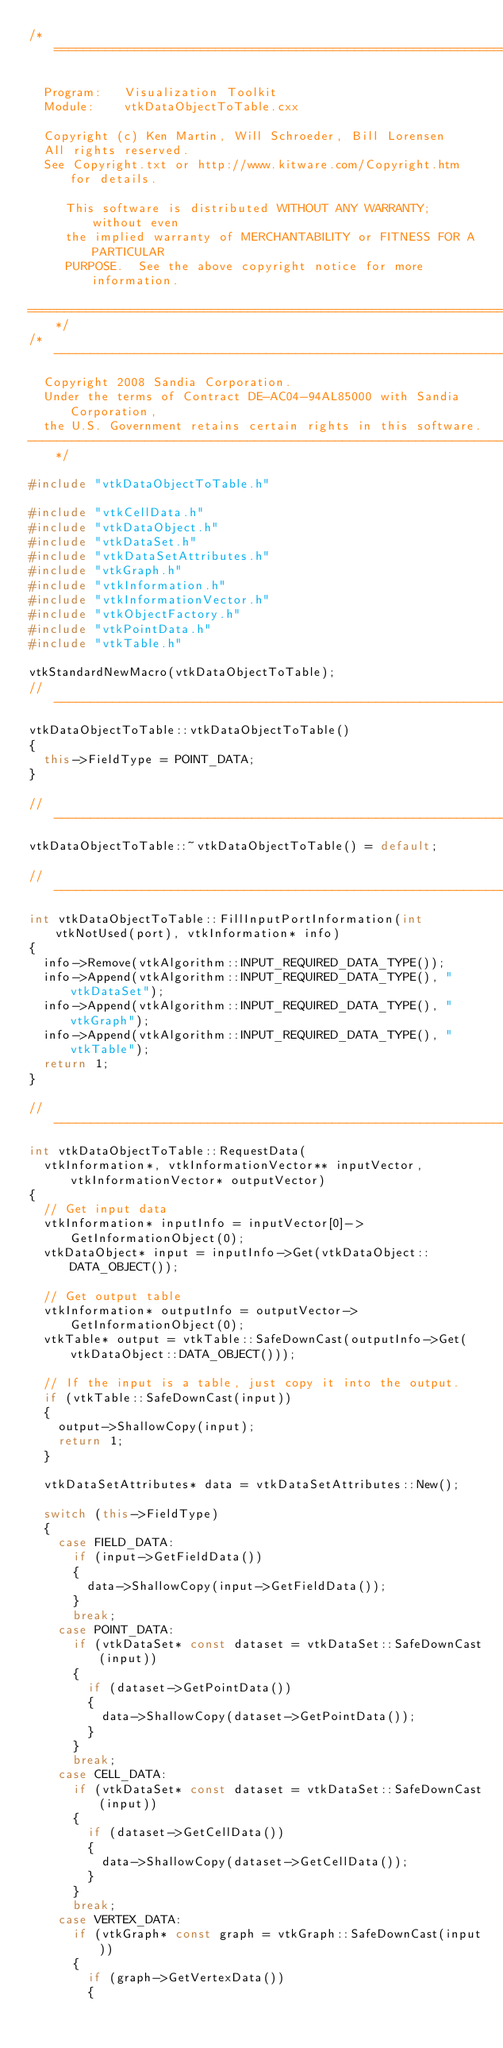Convert code to text. <code><loc_0><loc_0><loc_500><loc_500><_C++_>/*=========================================================================

  Program:   Visualization Toolkit
  Module:    vtkDataObjectToTable.cxx

  Copyright (c) Ken Martin, Will Schroeder, Bill Lorensen
  All rights reserved.
  See Copyright.txt or http://www.kitware.com/Copyright.htm for details.

     This software is distributed WITHOUT ANY WARRANTY; without even
     the implied warranty of MERCHANTABILITY or FITNESS FOR A PARTICULAR
     PURPOSE.  See the above copyright notice for more information.

=========================================================================*/
/*-------------------------------------------------------------------------
  Copyright 2008 Sandia Corporation.
  Under the terms of Contract DE-AC04-94AL85000 with Sandia Corporation,
  the U.S. Government retains certain rights in this software.
-------------------------------------------------------------------------*/

#include "vtkDataObjectToTable.h"

#include "vtkCellData.h"
#include "vtkDataObject.h"
#include "vtkDataSet.h"
#include "vtkDataSetAttributes.h"
#include "vtkGraph.h"
#include "vtkInformation.h"
#include "vtkInformationVector.h"
#include "vtkObjectFactory.h"
#include "vtkPointData.h"
#include "vtkTable.h"

vtkStandardNewMacro(vtkDataObjectToTable);
//------------------------------------------------------------------------------
vtkDataObjectToTable::vtkDataObjectToTable()
{
  this->FieldType = POINT_DATA;
}

//------------------------------------------------------------------------------
vtkDataObjectToTable::~vtkDataObjectToTable() = default;

//------------------------------------------------------------------------------
int vtkDataObjectToTable::FillInputPortInformation(int vtkNotUsed(port), vtkInformation* info)
{
  info->Remove(vtkAlgorithm::INPUT_REQUIRED_DATA_TYPE());
  info->Append(vtkAlgorithm::INPUT_REQUIRED_DATA_TYPE(), "vtkDataSet");
  info->Append(vtkAlgorithm::INPUT_REQUIRED_DATA_TYPE(), "vtkGraph");
  info->Append(vtkAlgorithm::INPUT_REQUIRED_DATA_TYPE(), "vtkTable");
  return 1;
}

//------------------------------------------------------------------------------
int vtkDataObjectToTable::RequestData(
  vtkInformation*, vtkInformationVector** inputVector, vtkInformationVector* outputVector)
{
  // Get input data
  vtkInformation* inputInfo = inputVector[0]->GetInformationObject(0);
  vtkDataObject* input = inputInfo->Get(vtkDataObject::DATA_OBJECT());

  // Get output table
  vtkInformation* outputInfo = outputVector->GetInformationObject(0);
  vtkTable* output = vtkTable::SafeDownCast(outputInfo->Get(vtkDataObject::DATA_OBJECT()));

  // If the input is a table, just copy it into the output.
  if (vtkTable::SafeDownCast(input))
  {
    output->ShallowCopy(input);
    return 1;
  }

  vtkDataSetAttributes* data = vtkDataSetAttributes::New();

  switch (this->FieldType)
  {
    case FIELD_DATA:
      if (input->GetFieldData())
      {
        data->ShallowCopy(input->GetFieldData());
      }
      break;
    case POINT_DATA:
      if (vtkDataSet* const dataset = vtkDataSet::SafeDownCast(input))
      {
        if (dataset->GetPointData())
        {
          data->ShallowCopy(dataset->GetPointData());
        }
      }
      break;
    case CELL_DATA:
      if (vtkDataSet* const dataset = vtkDataSet::SafeDownCast(input))
      {
        if (dataset->GetCellData())
        {
          data->ShallowCopy(dataset->GetCellData());
        }
      }
      break;
    case VERTEX_DATA:
      if (vtkGraph* const graph = vtkGraph::SafeDownCast(input))
      {
        if (graph->GetVertexData())
        {</code> 